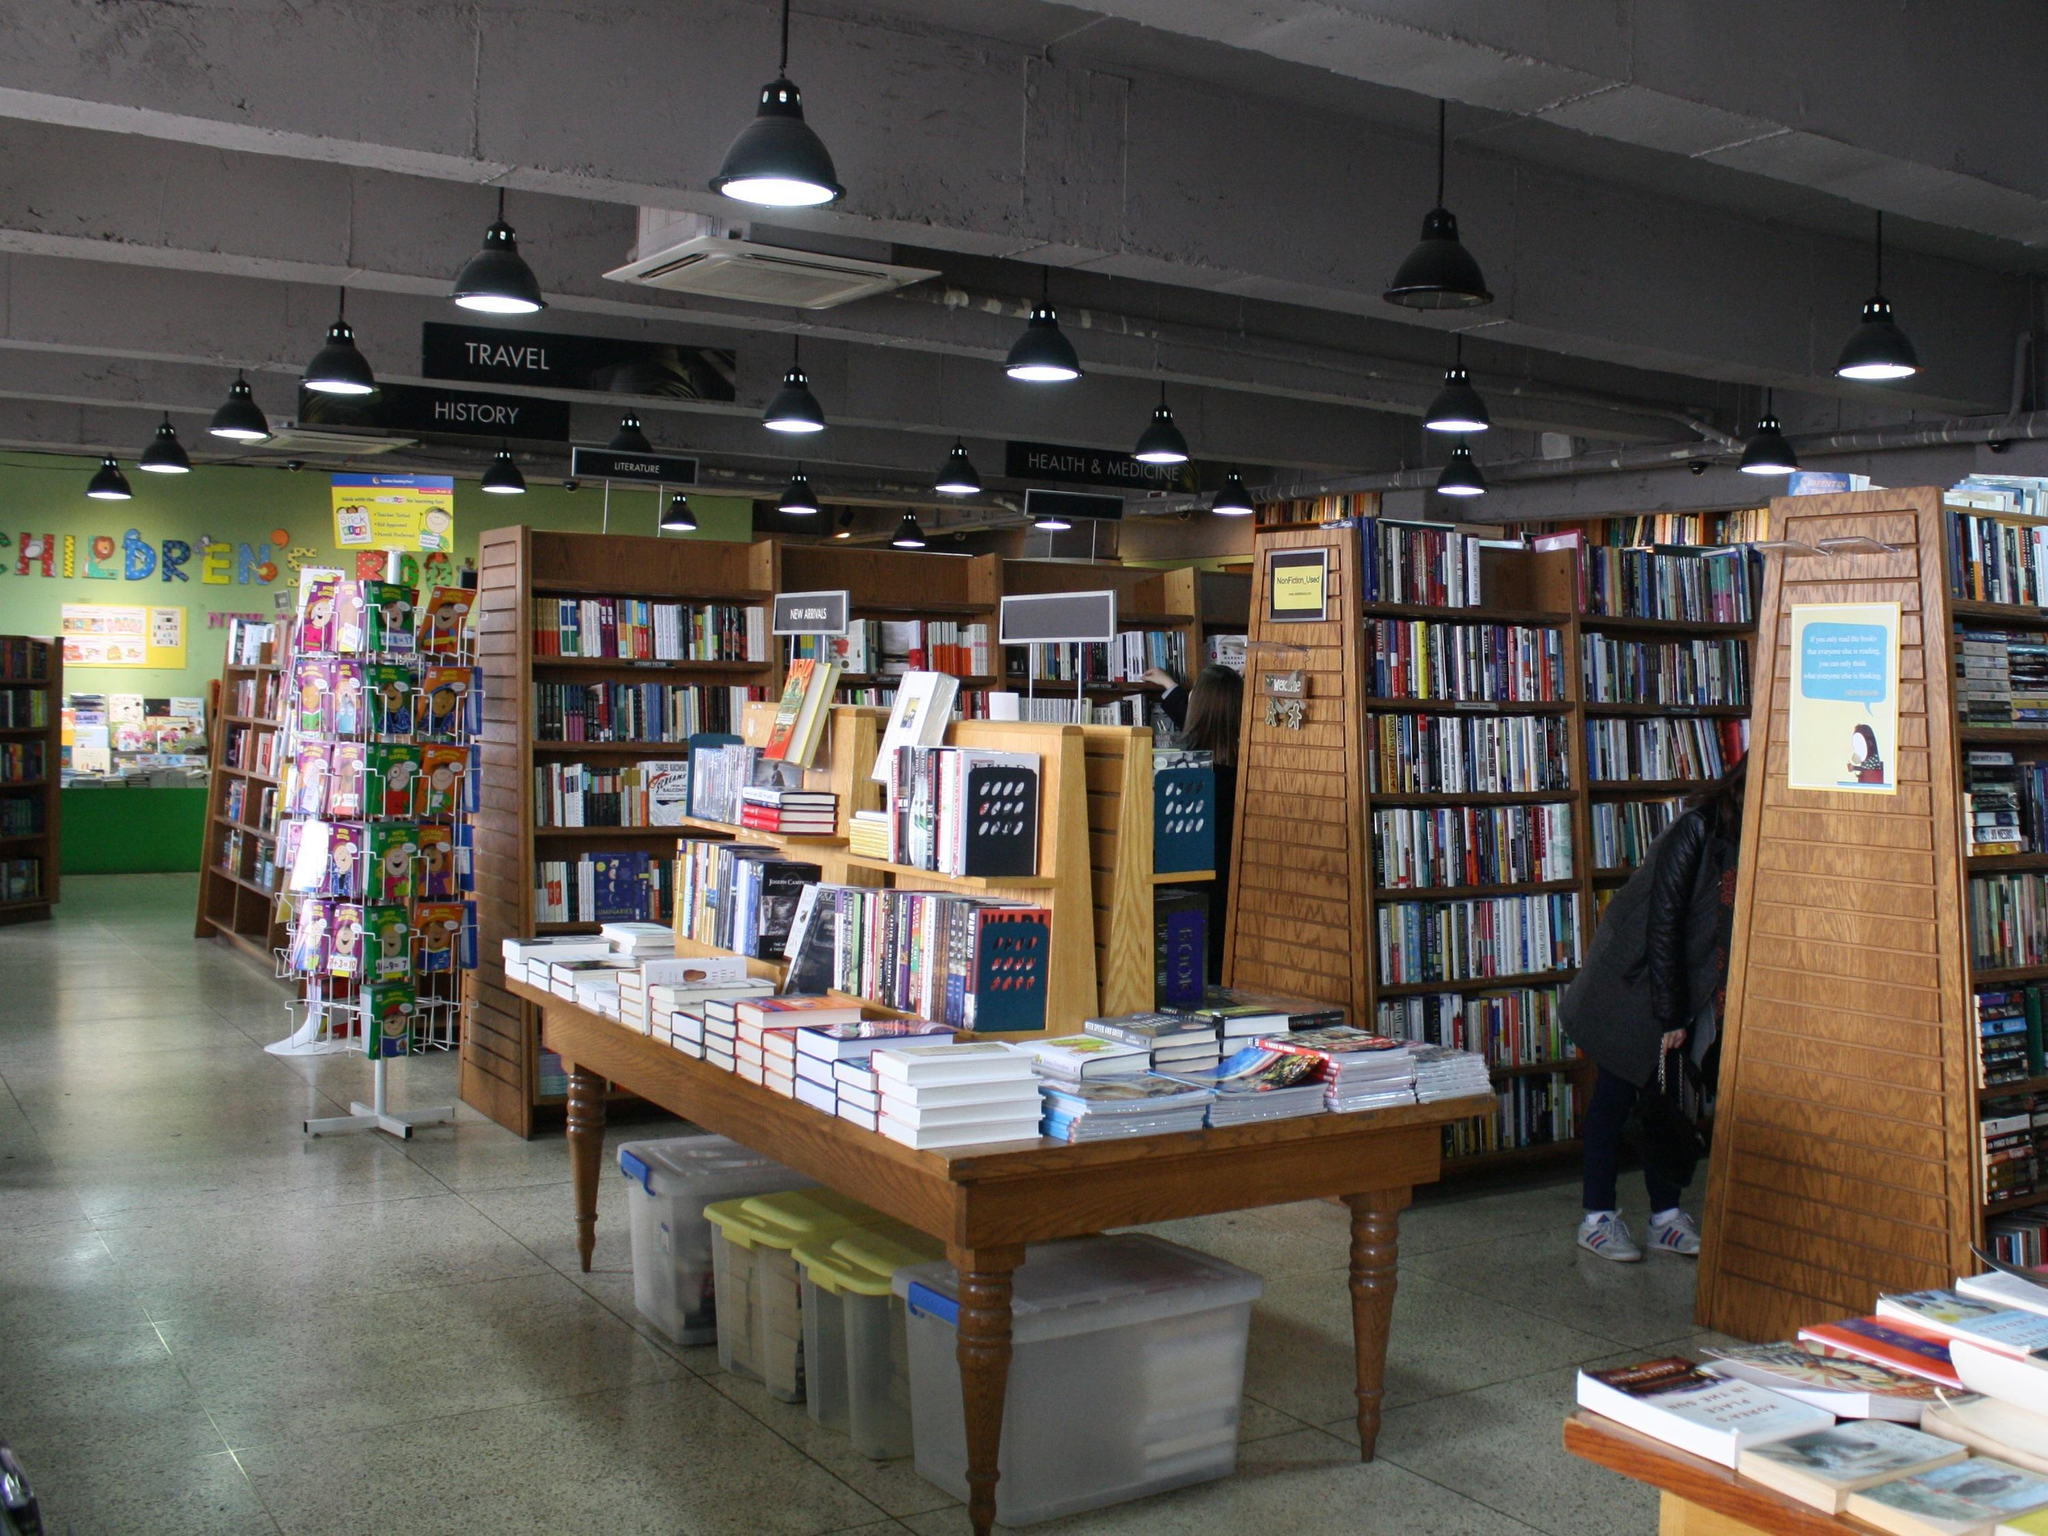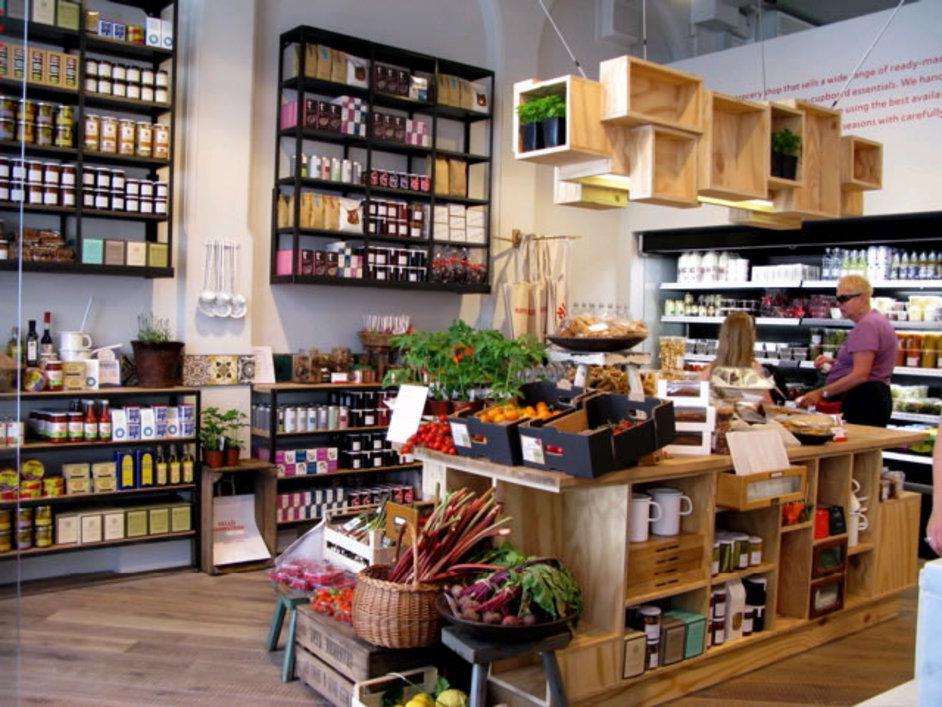The first image is the image on the left, the second image is the image on the right. Considering the images on both sides, is "The left image shows the exterior of a shop with dark green signage and at least one table of items in front of one of the square glass windows flanking a single door." valid? Answer yes or no. No. 